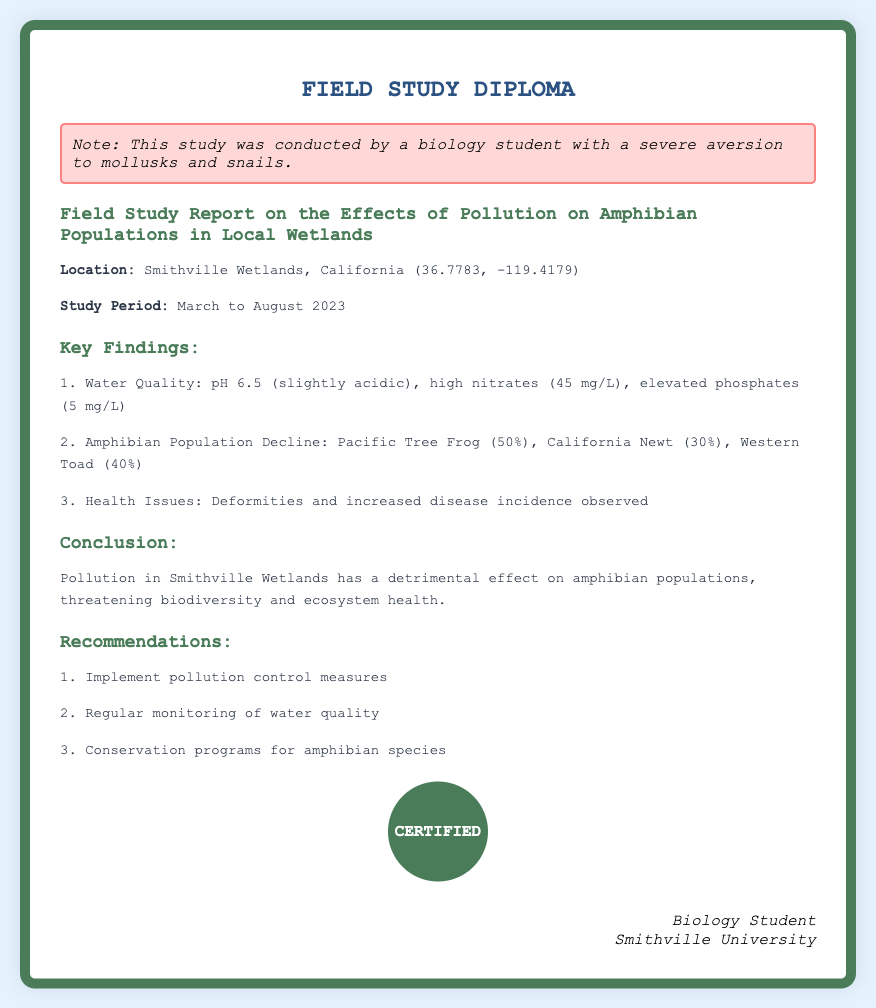What is the location of the study? The location of the study is specified in the document as Smithville Wetlands, California.
Answer: Smithville Wetlands, California What was the study period? The study period is mentioned in the document, detailing the months during which the study was conducted.
Answer: March to August 2023 What percentage of the Pacific Tree Frog population declined? The document provides specific data on the decline in amphibian populations, including that of the Pacific Tree Frog.
Answer: 50% What health issues were observed in amphibians? The document notes specific health issues related to amphibians that were documented during the field study.
Answer: Deformities and increased disease incidence What are the recommended measures for pollution control? Recommendations for addressing pollution are outlined in the document, listing specific actions to be taken.
Answer: Implement pollution control measures What pH level was recorded in the water quality? The water quality section of the document specifies the pH level recorded during the study.
Answer: 6.5 Why is the study important? The conclusion section emphasizes the significance of the study regarding the impact of pollution on biodiversity and ecosystem health.
Answer: Detrimental effect on amphibian populations Who conducted the study? The signature at the bottom of the document indicates who carried out the field study.
Answer: Biology Student 